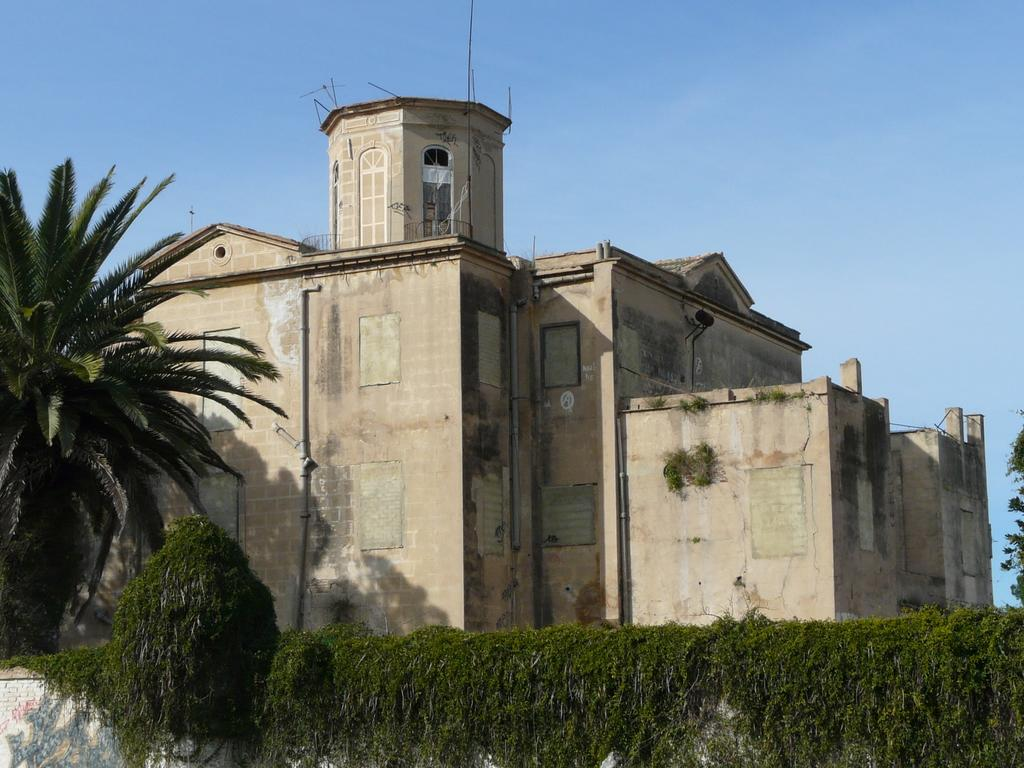What type of structures can be seen in the image? There are buildings in the image. What type of vegetation is present in the image? There are trees in the image. How does the image show an increase in the number of walls? The image does not show an increase in the number of walls; it simply depicts buildings and trees. What type of shop can be seen in the image? There is no shop present in the image; it only features buildings and trees. 